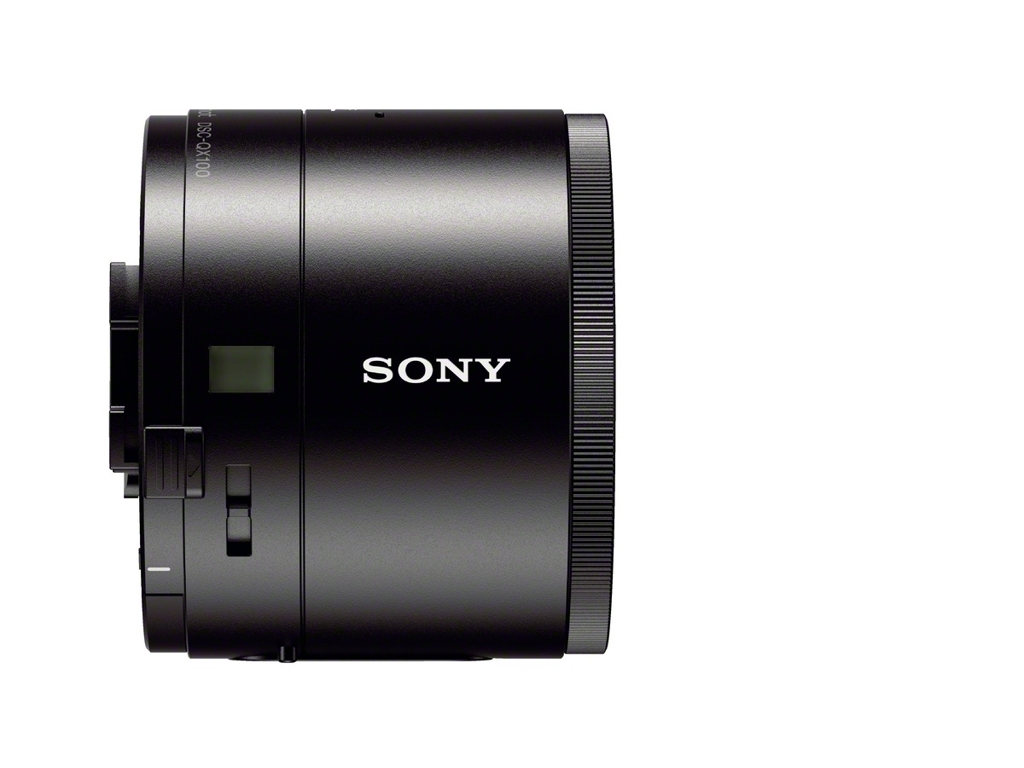It looks quite advanced, does it have any special features? While the image doesn't provide detailed specifications, the design suggests it might offer features like autofocus, given the visible electronic contacts, and potentially high-quality optics based on the branding. 